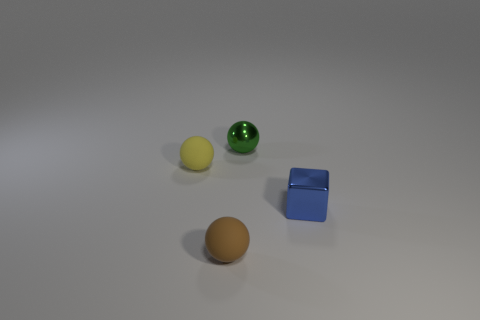Add 1 green things. How many objects exist? 5 Subtract all balls. How many objects are left? 1 Subtract 1 green balls. How many objects are left? 3 Subtract all blocks. Subtract all small yellow rubber spheres. How many objects are left? 2 Add 3 small green metal spheres. How many small green metal spheres are left? 4 Add 4 tiny blue metallic cubes. How many tiny blue metallic cubes exist? 5 